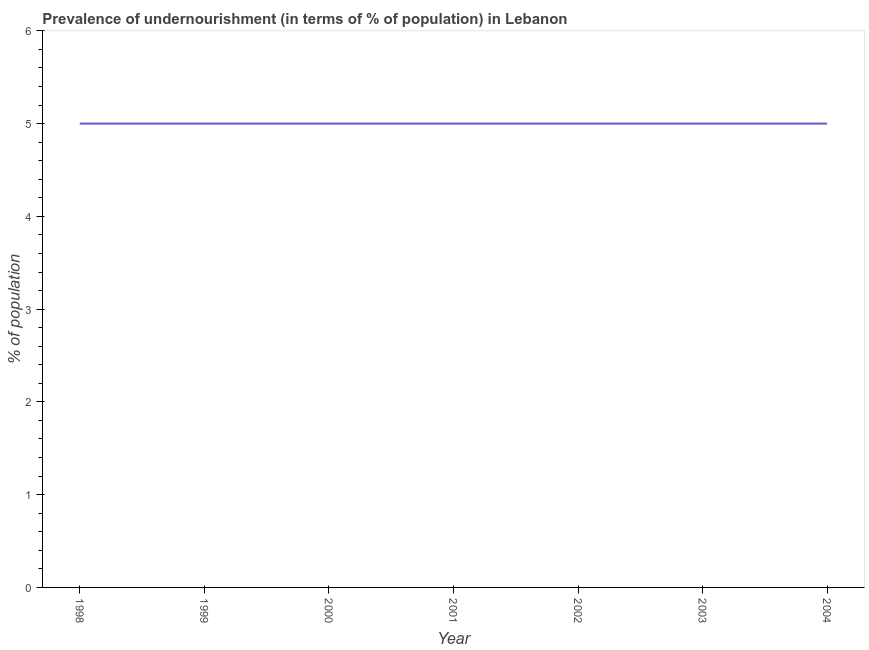What is the percentage of undernourished population in 1998?
Provide a succinct answer. 5. Across all years, what is the maximum percentage of undernourished population?
Offer a very short reply. 5. Across all years, what is the minimum percentage of undernourished population?
Your response must be concise. 5. In which year was the percentage of undernourished population maximum?
Ensure brevity in your answer.  1998. In which year was the percentage of undernourished population minimum?
Your answer should be very brief. 1998. What is the sum of the percentage of undernourished population?
Your response must be concise. 35. What is the difference between the percentage of undernourished population in 1999 and 2001?
Your response must be concise. 0. What is the average percentage of undernourished population per year?
Make the answer very short. 5. In how many years, is the percentage of undernourished population greater than 1.6 %?
Provide a short and direct response. 7. Is the percentage of undernourished population in 2000 less than that in 2002?
Offer a terse response. No. What is the difference between the highest and the second highest percentage of undernourished population?
Your answer should be compact. 0. Is the sum of the percentage of undernourished population in 1998 and 2002 greater than the maximum percentage of undernourished population across all years?
Make the answer very short. Yes. What is the difference between the highest and the lowest percentage of undernourished population?
Offer a terse response. 0. In how many years, is the percentage of undernourished population greater than the average percentage of undernourished population taken over all years?
Offer a very short reply. 0. How many years are there in the graph?
Provide a short and direct response. 7. Does the graph contain any zero values?
Offer a very short reply. No. What is the title of the graph?
Your response must be concise. Prevalence of undernourishment (in terms of % of population) in Lebanon. What is the label or title of the X-axis?
Provide a succinct answer. Year. What is the label or title of the Y-axis?
Give a very brief answer. % of population. What is the % of population of 1998?
Your response must be concise. 5. What is the % of population of 2000?
Your response must be concise. 5. What is the % of population of 2001?
Provide a succinct answer. 5. What is the % of population in 2002?
Ensure brevity in your answer.  5. What is the % of population in 2003?
Provide a short and direct response. 5. What is the difference between the % of population in 1998 and 1999?
Keep it short and to the point. 0. What is the difference between the % of population in 1999 and 2000?
Keep it short and to the point. 0. What is the difference between the % of population in 1999 and 2004?
Ensure brevity in your answer.  0. What is the difference between the % of population in 2000 and 2003?
Ensure brevity in your answer.  0. What is the difference between the % of population in 2001 and 2002?
Offer a terse response. 0. What is the difference between the % of population in 2001 and 2003?
Keep it short and to the point. 0. What is the difference between the % of population in 2001 and 2004?
Ensure brevity in your answer.  0. What is the difference between the % of population in 2002 and 2003?
Your answer should be very brief. 0. What is the difference between the % of population in 2003 and 2004?
Offer a very short reply. 0. What is the ratio of the % of population in 1998 to that in 1999?
Keep it short and to the point. 1. What is the ratio of the % of population in 1999 to that in 2002?
Your answer should be compact. 1. What is the ratio of the % of population in 1999 to that in 2004?
Offer a terse response. 1. What is the ratio of the % of population in 2000 to that in 2003?
Ensure brevity in your answer.  1. What is the ratio of the % of population in 2001 to that in 2003?
Make the answer very short. 1. What is the ratio of the % of population in 2002 to that in 2004?
Offer a very short reply. 1. What is the ratio of the % of population in 2003 to that in 2004?
Provide a short and direct response. 1. 